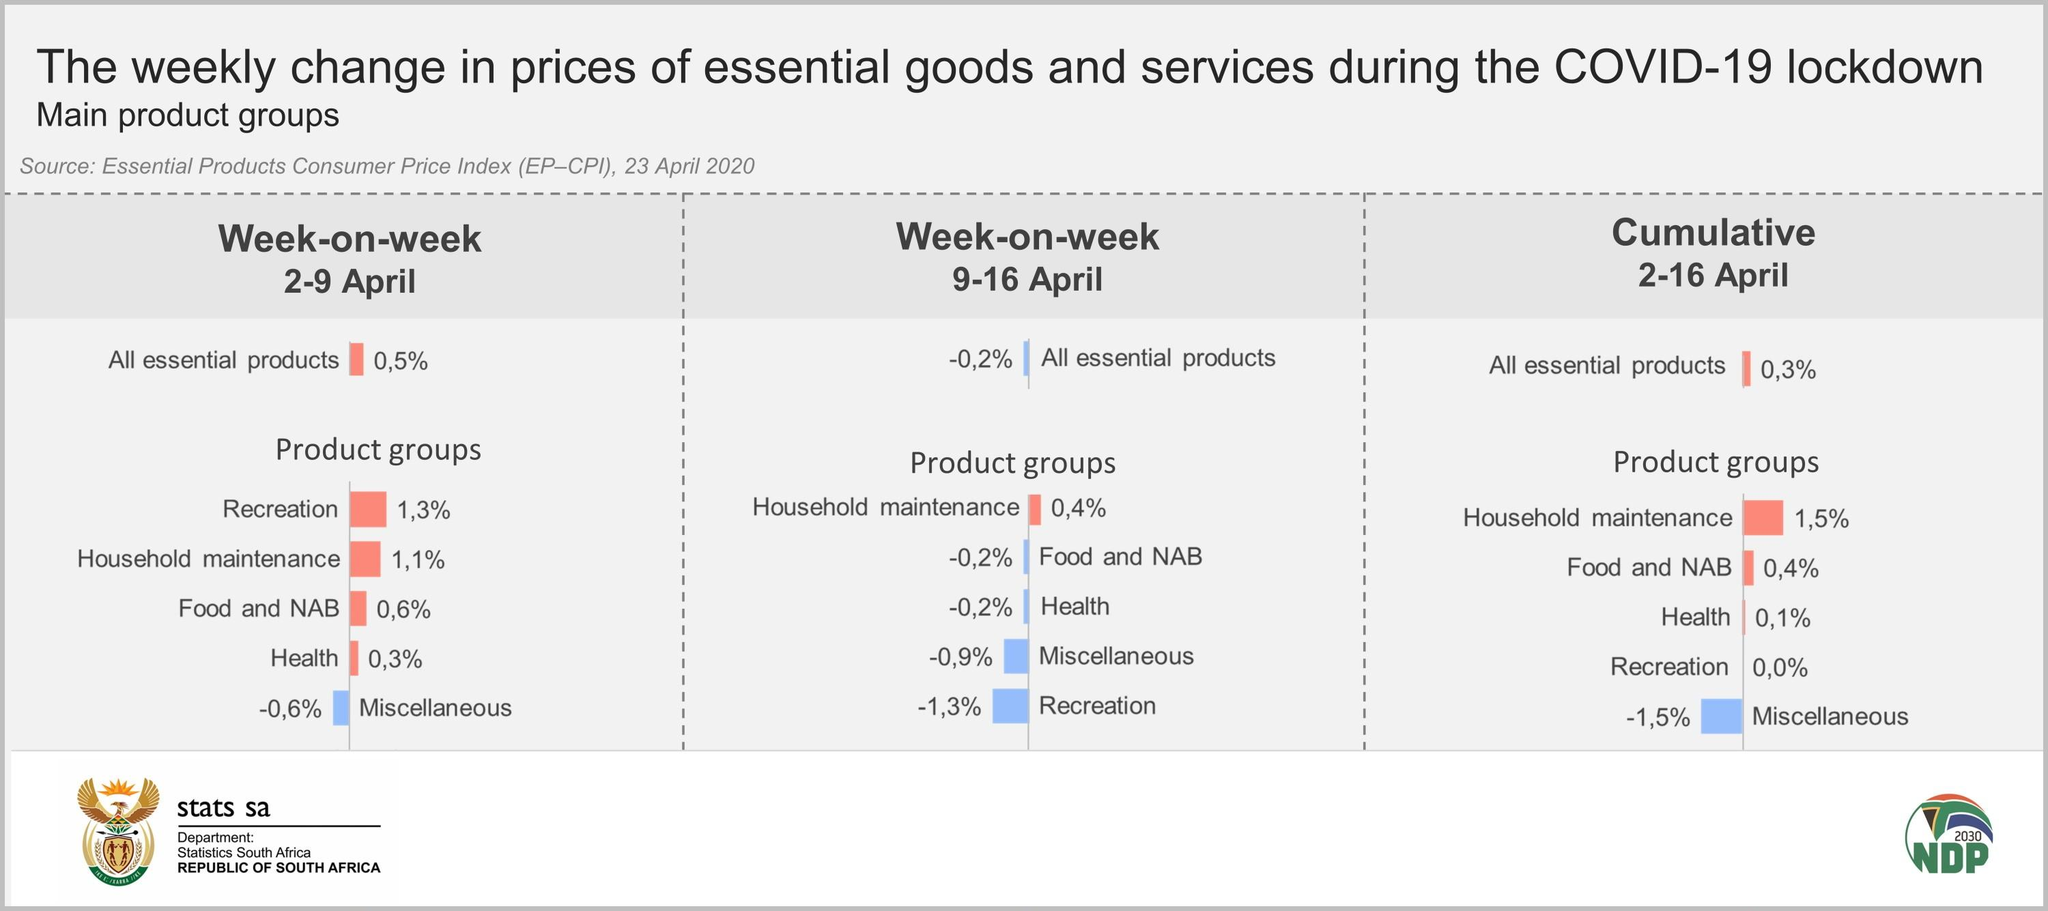Outline some significant characteristics in this image. The percentage change in food and NAB prices in the weeks of April 2-9 and April 9-16 were 0.8%, indicating a slight increase in these prices. The price of household maintenance increased by 0.7% between weeks 2-9 April and 9-16 April. In the week of April 9-16, the price of the recreation product group decreased at the highest rate. The difference in the percentage change of the price of health between the week of April 2-9 and the week of April 9-16 was 0.5%. During the week of April 9-16, the price of the food and NAB group decreased at the lowest rate. 